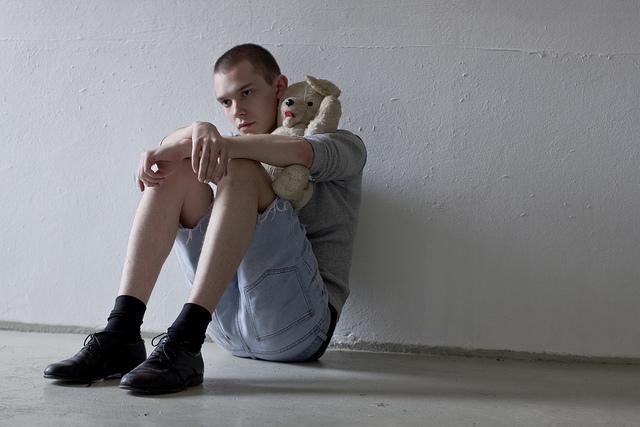How many people are in this picture?
Give a very brief answer. 1. How many people are shown?
Give a very brief answer. 1. 